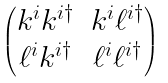<formula> <loc_0><loc_0><loc_500><loc_500>\begin{pmatrix} k ^ { i } k ^ { i \dag } & k ^ { i } \ell ^ { i \dag } \\ \ell ^ { i } k ^ { i \dag } & \ell ^ { i } \ell ^ { i \dag } \end{pmatrix}</formula> 